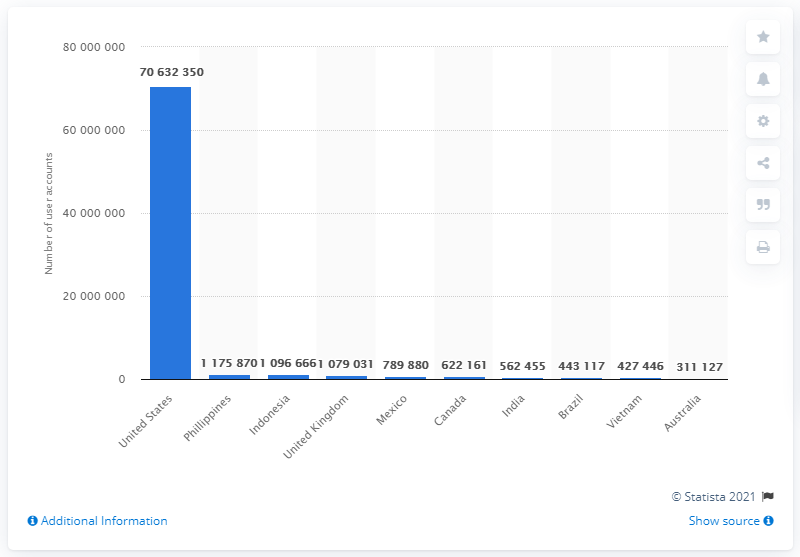Indicate a few pertinent items in this graphic. In April 2018, approximately 70632350 Facebook user accounts in the United States were compromised. 